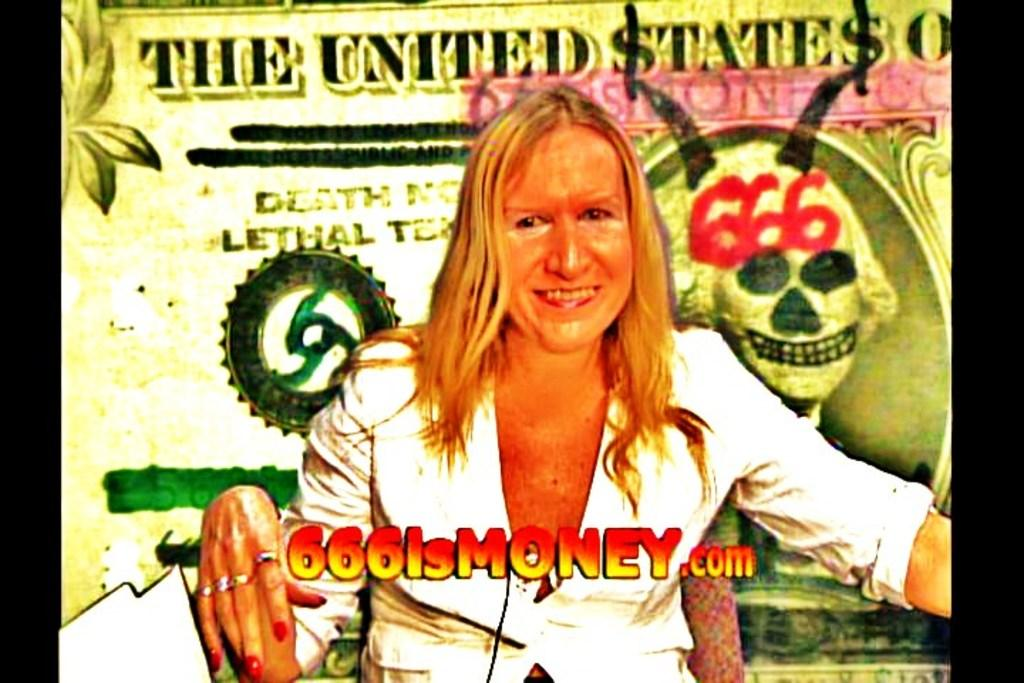Who is present in the image? There is a lady in the image. What is behind the lady in the image? There is a poster behind the lady. What elements can be found on the poster? The poster contains text, images, and numbers. How are the elements on the poster framed? The poster has black borders. Where is the bucket located in the image? There is no bucket present in the image. How many people are in the group in the image? There is no group of people present in the image; only a lady and a poster are visible. 